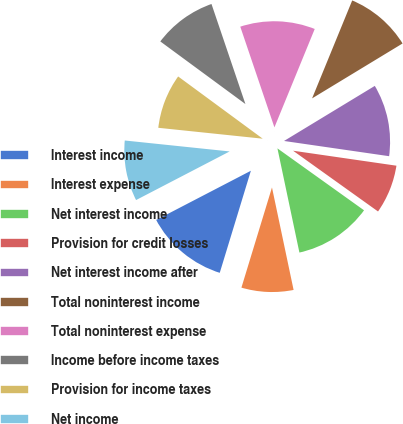<chart> <loc_0><loc_0><loc_500><loc_500><pie_chart><fcel>Interest income<fcel>Interest expense<fcel>Net interest income<fcel>Provision for credit losses<fcel>Net interest income after<fcel>Total noninterest income<fcel>Total noninterest expense<fcel>Income before income taxes<fcel>Provision for income taxes<fcel>Net income<nl><fcel>12.66%<fcel>8.02%<fcel>11.81%<fcel>7.59%<fcel>10.97%<fcel>10.13%<fcel>11.39%<fcel>9.7%<fcel>8.44%<fcel>9.28%<nl></chart> 